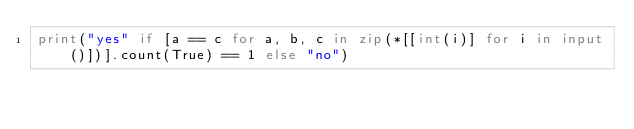<code> <loc_0><loc_0><loc_500><loc_500><_Python_>print("yes" if [a == c for a, b, c in zip(*[[int(i)] for i in input()])].count(True) == 1 else "no")</code> 